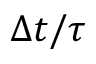<formula> <loc_0><loc_0><loc_500><loc_500>\Delta t / \tau</formula> 